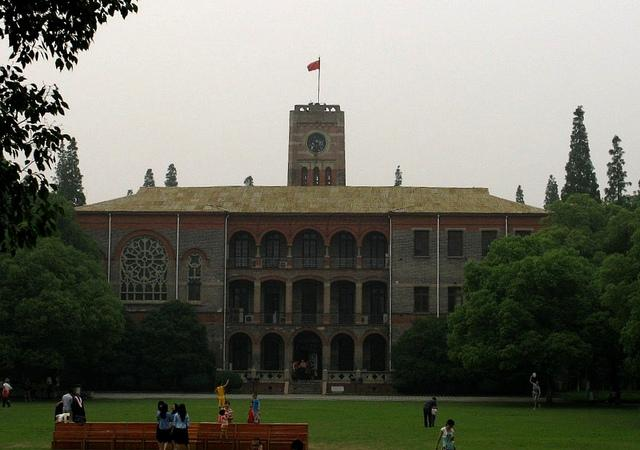What type of building is this most probably looking at the people in the courtyard? school 